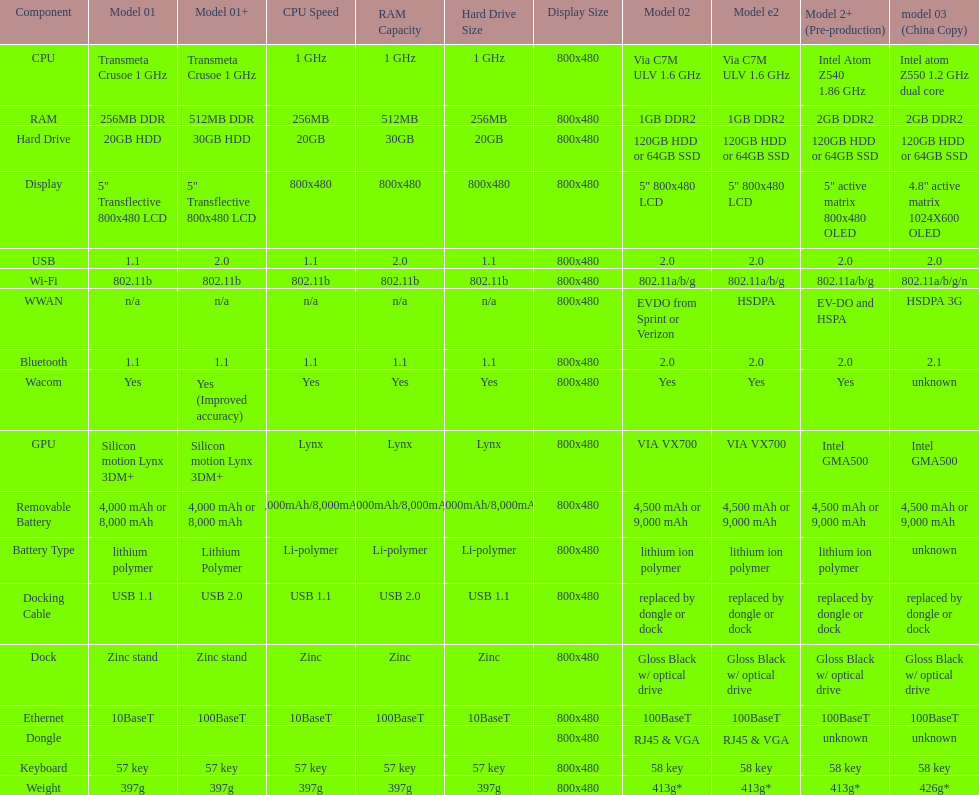What is the component before usb? Display. 